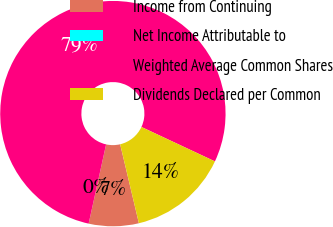Convert chart. <chart><loc_0><loc_0><loc_500><loc_500><pie_chart><fcel>Income from Continuing<fcel>Net Income Attributable to<fcel>Weighted Average Common Shares<fcel>Dividends Declared per Common<nl><fcel>7.16%<fcel>0.0%<fcel>78.52%<fcel>14.32%<nl></chart> 